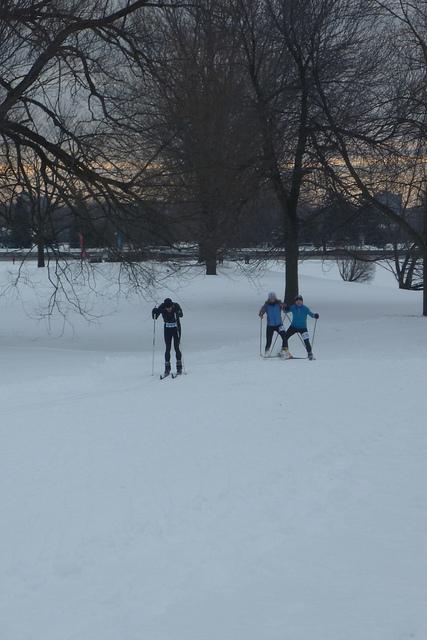How many people are there?
Answer briefly. 3. Is there snow on the ground?
Be succinct. Yes. Are they practicing?
Keep it brief. Yes. Are people flying a kite in the winter?
Be succinct. No. Is the sun setting?
Give a very brief answer. Yes. 